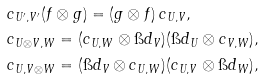<formula> <loc_0><loc_0><loc_500><loc_500>& c _ { U ^ { \prime } , V ^ { \prime } } ( f \otimes g ) = ( g \otimes f ) \, c _ { U , V } , \\ & c _ { U \otimes V , W } = ( c _ { U , W } \otimes \i d _ { V } ) ( \i d _ { U } \otimes c _ { V , W } ) , \\ & c _ { U , V \otimes W } = ( \i d _ { V } \otimes c _ { U , W } ) ( c _ { U , V } \otimes \i d _ { W } ) ,</formula> 